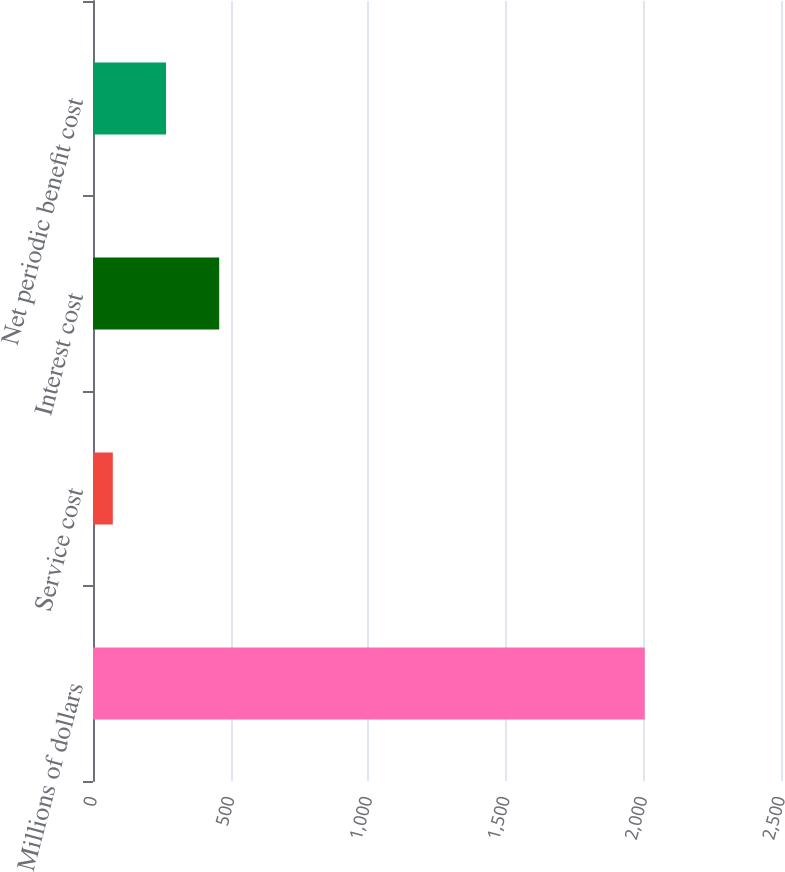<chart> <loc_0><loc_0><loc_500><loc_500><bar_chart><fcel>Millions of dollars<fcel>Service cost<fcel>Interest cost<fcel>Net periodic benefit cost<nl><fcel>2005<fcel>72<fcel>458.6<fcel>265.3<nl></chart> 